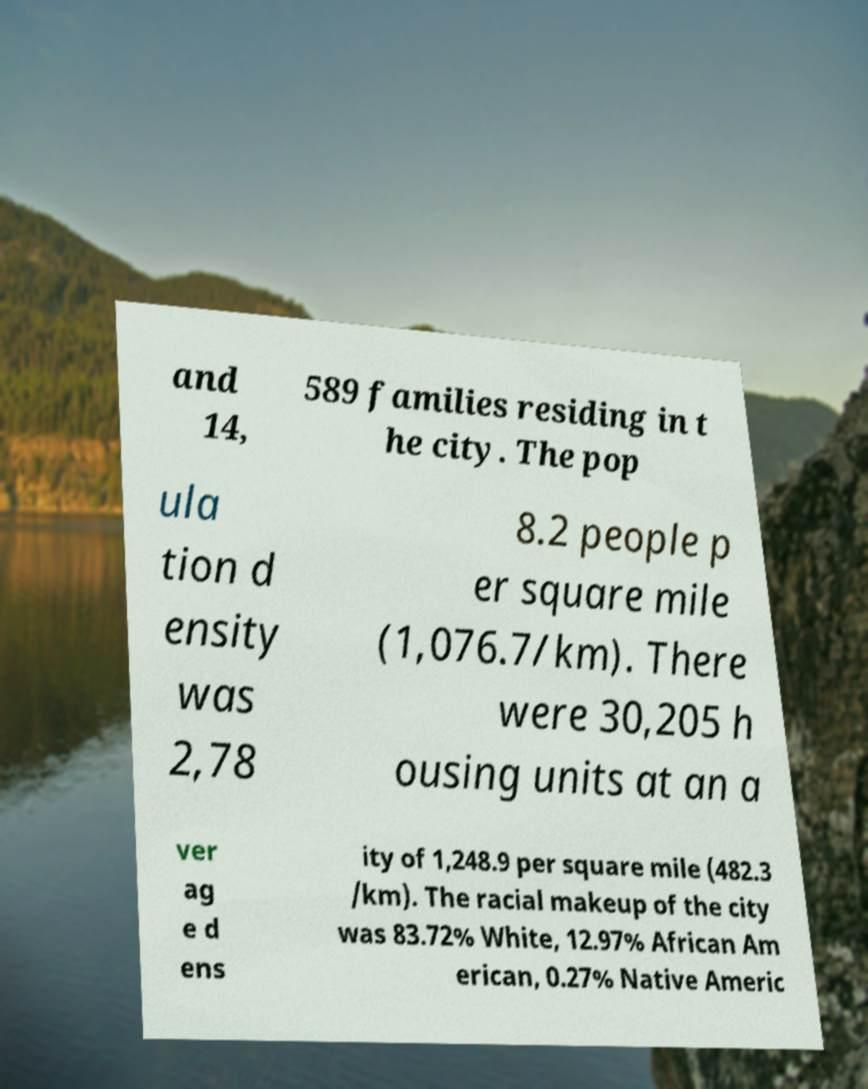Could you assist in decoding the text presented in this image and type it out clearly? and 14, 589 families residing in t he city. The pop ula tion d ensity was 2,78 8.2 people p er square mile (1,076.7/km). There were 30,205 h ousing units at an a ver ag e d ens ity of 1,248.9 per square mile (482.3 /km). The racial makeup of the city was 83.72% White, 12.97% African Am erican, 0.27% Native Americ 